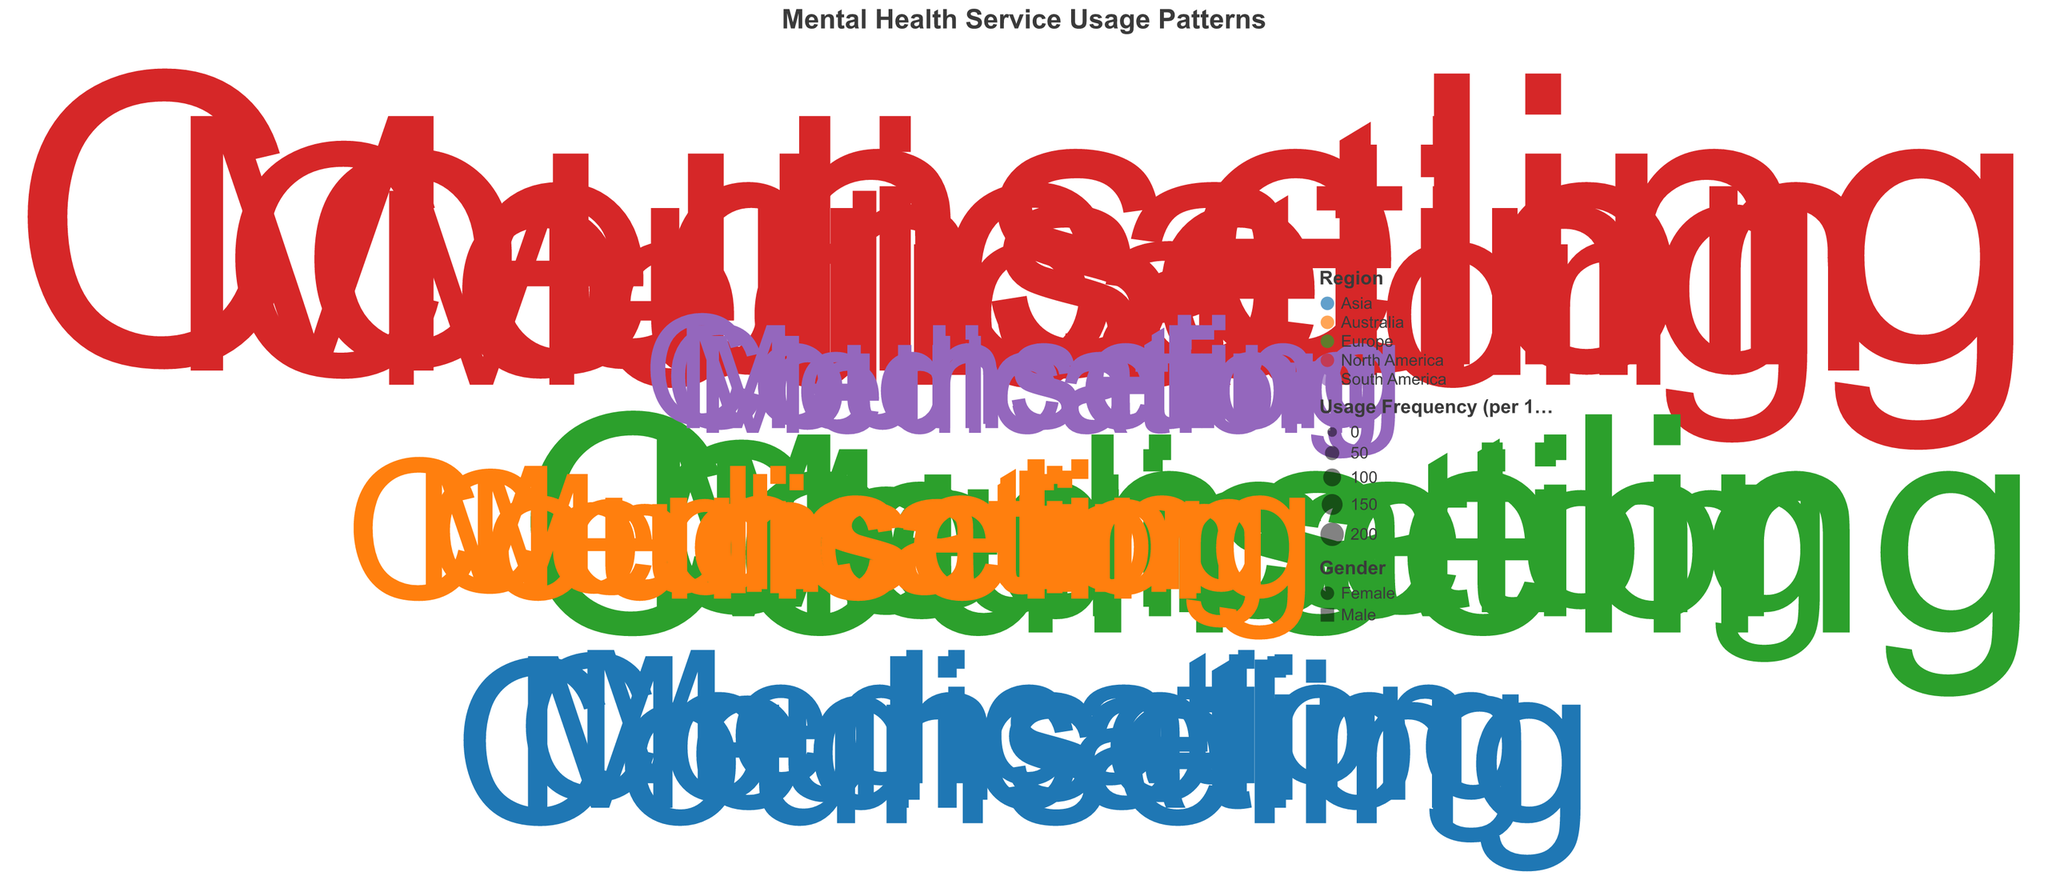What is the title of the figure? The title is located at the top of the figure. It directly indicates the main subject of the visualization.
Answer: Mental Health Service Usage Patterns Which region has the highest frequency of Counseling usage among females aged 18-25? Look at the data points for the age group 18-25, filtered by female gender, corresponding to Counseling. The color will indicate the region with the highest frequency.
Answer: North America What is the difference in Counseling usage frequency between males and females aged 36-45 in Asia? Identify the Counseling usage frequencies for males and females aged 36-45 in Asia and subtract the male usage frequency from the female usage frequency.
Answer: 15 (95 - 80 = 15) How does the usage frequency of Medication for males aged 60+ in South America compare to that of females aged 60+ in the same region? Look for the data points of Medication usage for both genders aged 60+ in South America and compare their frequencies.
Answer: Males use less than females (40 vs. 45) Which age group and gender have the lowest usage of Medication services, and what is the frequency? Identify the data point with the lowest frequency for Medication services across all age groups and genders.
Answer: Males aged 60+ with a frequency of 40 What is the combined Counseling usage frequency for all individuals aged 26-35 in Europe? Sum the Counseling usage frequencies for both males and females aged 26-35 in Europe.
Answer: 240 (100 + 140 = 240) Are males or females more frequent users of mental health services overall in North America for the 18-25 age group? Sum the Counseling and Medication usage frequencies for both genders in the 18-25 age group in North America and compare the totals.
Answer: Females (200 + 170 = 370, whereas Males is 270) Which mental health service type (Counseling or Medication) has the highest variability in usage frequency across all age groups? Compare the ranges (difference between max and min values) of usage frequencies for both Counseling and Medication services.
Answer: Counseling (range is 200 - 45 = 155) What shape is used to differentiate gender in the chart? Look at the legend or the shape of the data points in the chart. Each gender is represented by different shapes.
Answer: Different shapes How does the trend of Counseling usage frequency change with age for females? Observe the Counseling usage frequencies for females in different age groups and note the trend as the age increases.
Answer: Decreases with age 